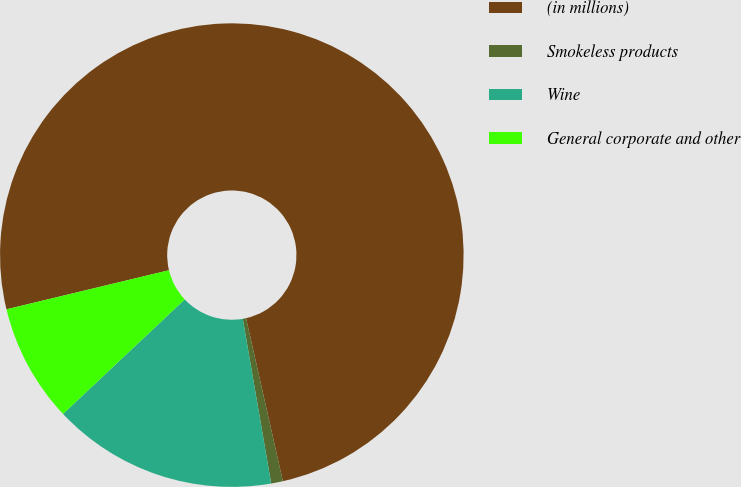Convert chart. <chart><loc_0><loc_0><loc_500><loc_500><pie_chart><fcel>(in millions)<fcel>Smokeless products<fcel>Wine<fcel>General corporate and other<nl><fcel>75.22%<fcel>0.82%<fcel>15.7%<fcel>8.26%<nl></chart> 